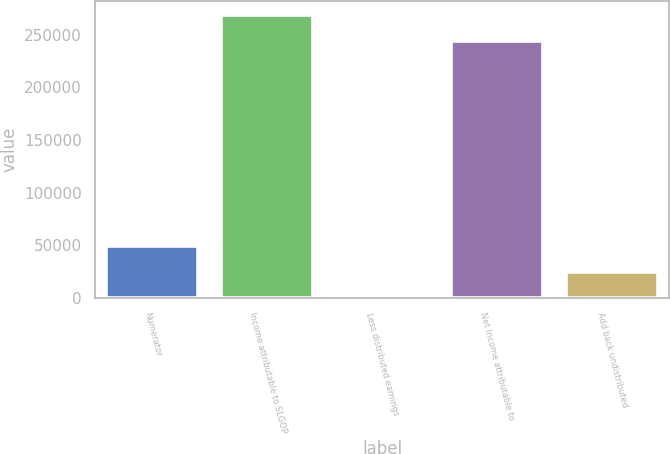Convert chart to OTSL. <chart><loc_0><loc_0><loc_500><loc_500><bar_chart><fcel>Numerator<fcel>Income attributable to SLGOP<fcel>Less distributed earnings<fcel>Net Income attributable to<fcel>Add back undistributed<nl><fcel>49347.2<fcel>268374<fcel>552<fcel>243976<fcel>24949.6<nl></chart> 